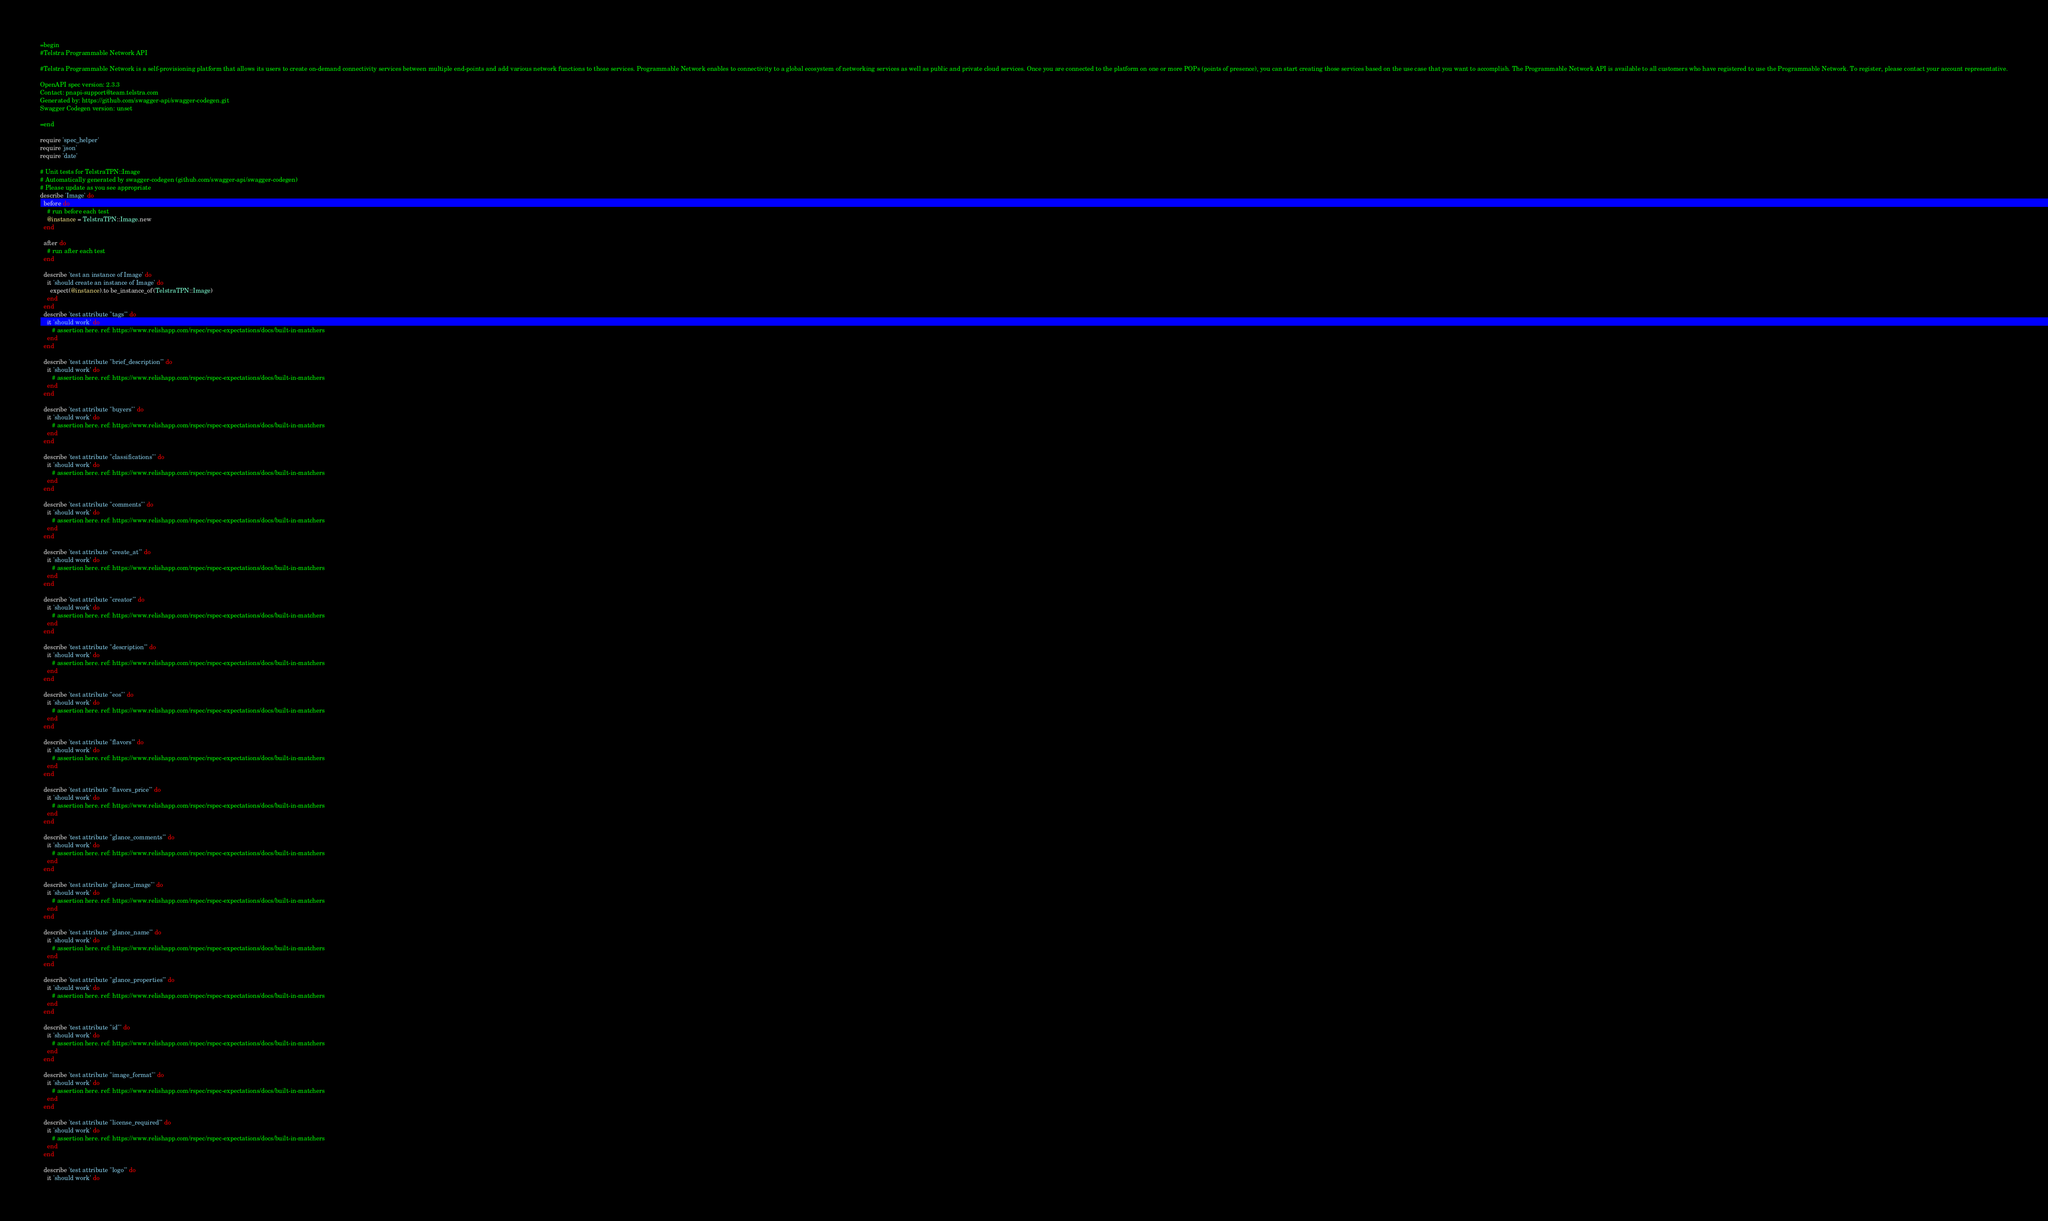<code> <loc_0><loc_0><loc_500><loc_500><_Ruby_>=begin
#Telstra Programmable Network API

#Telstra Programmable Network is a self-provisioning platform that allows its users to create on-demand connectivity services between multiple end-points and add various network functions to those services. Programmable Network enables to connectivity to a global ecosystem of networking services as well as public and private cloud services. Once you are connected to the platform on one or more POPs (points of presence), you can start creating those services based on the use case that you want to accomplish. The Programmable Network API is available to all customers who have registered to use the Programmable Network. To register, please contact your account representative.

OpenAPI spec version: 2.3.3
Contact: pnapi-support@team.telstra.com
Generated by: https://github.com/swagger-api/swagger-codegen.git
Swagger Codegen version: unset

=end

require 'spec_helper'
require 'json'
require 'date'

# Unit tests for TelstraTPN::Image
# Automatically generated by swagger-codegen (github.com/swagger-api/swagger-codegen)
# Please update as you see appropriate
describe 'Image' do
  before do
    # run before each test
    @instance = TelstraTPN::Image.new
  end

  after do
    # run after each test
  end

  describe 'test an instance of Image' do
    it 'should create an instance of Image' do
      expect(@instance).to be_instance_of(TelstraTPN::Image)
    end
  end
  describe 'test attribute "tags"' do
    it 'should work' do
       # assertion here. ref: https://www.relishapp.com/rspec/rspec-expectations/docs/built-in-matchers
    end
  end

  describe 'test attribute "brief_description"' do
    it 'should work' do
       # assertion here. ref: https://www.relishapp.com/rspec/rspec-expectations/docs/built-in-matchers
    end
  end

  describe 'test attribute "buyers"' do
    it 'should work' do
       # assertion here. ref: https://www.relishapp.com/rspec/rspec-expectations/docs/built-in-matchers
    end
  end

  describe 'test attribute "classifications"' do
    it 'should work' do
       # assertion here. ref: https://www.relishapp.com/rspec/rspec-expectations/docs/built-in-matchers
    end
  end

  describe 'test attribute "comments"' do
    it 'should work' do
       # assertion here. ref: https://www.relishapp.com/rspec/rspec-expectations/docs/built-in-matchers
    end
  end

  describe 'test attribute "create_at"' do
    it 'should work' do
       # assertion here. ref: https://www.relishapp.com/rspec/rspec-expectations/docs/built-in-matchers
    end
  end

  describe 'test attribute "creator"' do
    it 'should work' do
       # assertion here. ref: https://www.relishapp.com/rspec/rspec-expectations/docs/built-in-matchers
    end
  end

  describe 'test attribute "description"' do
    it 'should work' do
       # assertion here. ref: https://www.relishapp.com/rspec/rspec-expectations/docs/built-in-matchers
    end
  end

  describe 'test attribute "eos"' do
    it 'should work' do
       # assertion here. ref: https://www.relishapp.com/rspec/rspec-expectations/docs/built-in-matchers
    end
  end

  describe 'test attribute "flavors"' do
    it 'should work' do
       # assertion here. ref: https://www.relishapp.com/rspec/rspec-expectations/docs/built-in-matchers
    end
  end

  describe 'test attribute "flavors_price"' do
    it 'should work' do
       # assertion here. ref: https://www.relishapp.com/rspec/rspec-expectations/docs/built-in-matchers
    end
  end

  describe 'test attribute "glance_comments"' do
    it 'should work' do
       # assertion here. ref: https://www.relishapp.com/rspec/rspec-expectations/docs/built-in-matchers
    end
  end

  describe 'test attribute "glance_image"' do
    it 'should work' do
       # assertion here. ref: https://www.relishapp.com/rspec/rspec-expectations/docs/built-in-matchers
    end
  end

  describe 'test attribute "glance_name"' do
    it 'should work' do
       # assertion here. ref: https://www.relishapp.com/rspec/rspec-expectations/docs/built-in-matchers
    end
  end

  describe 'test attribute "glance_properties"' do
    it 'should work' do
       # assertion here. ref: https://www.relishapp.com/rspec/rspec-expectations/docs/built-in-matchers
    end
  end

  describe 'test attribute "id"' do
    it 'should work' do
       # assertion here. ref: https://www.relishapp.com/rspec/rspec-expectations/docs/built-in-matchers
    end
  end

  describe 'test attribute "image_format"' do
    it 'should work' do
       # assertion here. ref: https://www.relishapp.com/rspec/rspec-expectations/docs/built-in-matchers
    end
  end

  describe 'test attribute "license_required"' do
    it 'should work' do
       # assertion here. ref: https://www.relishapp.com/rspec/rspec-expectations/docs/built-in-matchers
    end
  end

  describe 'test attribute "logo"' do
    it 'should work' do</code> 